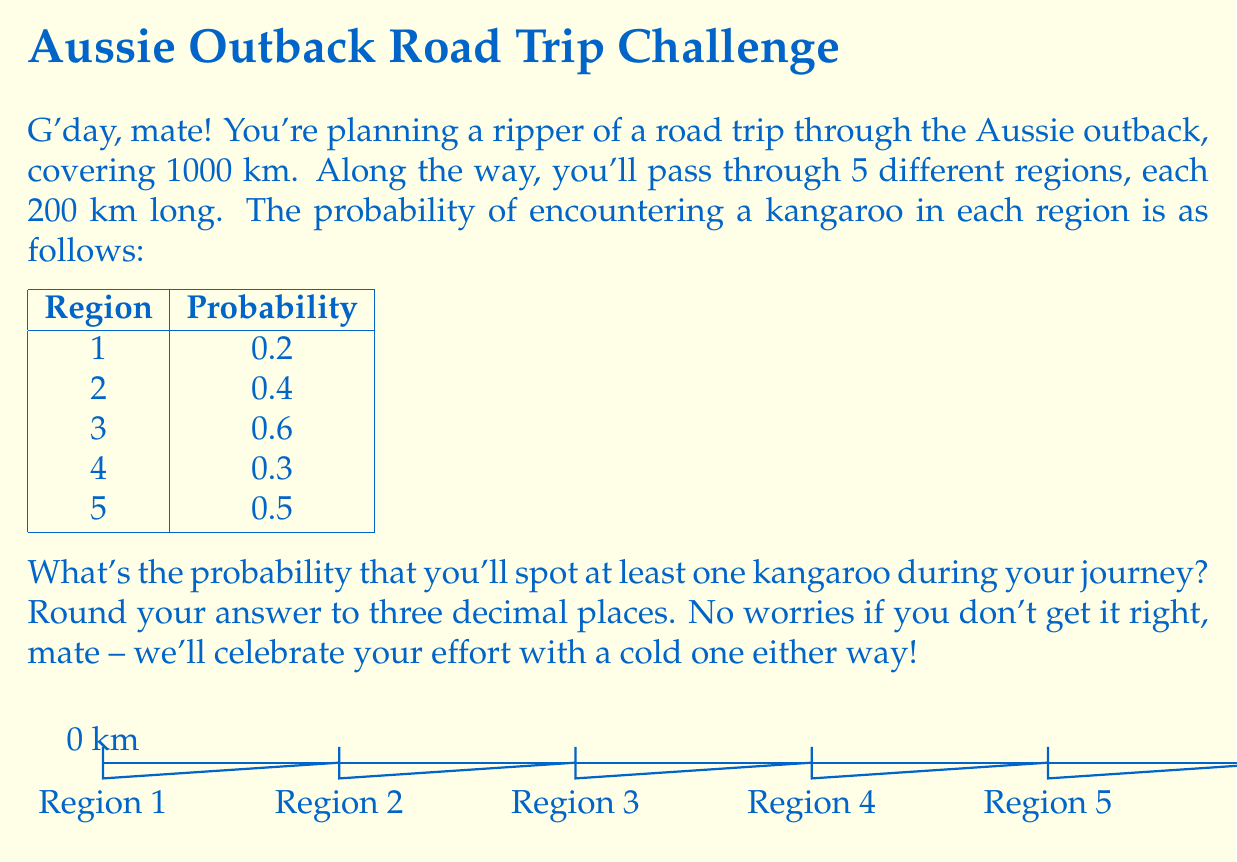Give your solution to this math problem. Let's tackle this problem step by step, mate:

1) First, we need to find the probability of not encountering a kangaroo in each region. This is simply 1 minus the probability of encountering a kangaroo:

   Region 1: $1 - 0.2 = 0.8$
   Region 2: $1 - 0.4 = 0.6$
   Region 3: $1 - 0.6 = 0.4$
   Region 4: $1 - 0.3 = 0.7$
   Region 5: $1 - 0.5 = 0.5$

2) Now, to find the probability of not encountering any kangaroos during the entire trip, we multiply these probabilities together:

   $P(\text{no kangaroos}) = 0.8 \times 0.6 \times 0.4 \times 0.7 \times 0.5$

3) Let's crunch those numbers:

   $P(\text{no kangaroos}) = 0.0672$

4) The probability of encountering at least one kangaroo is the opposite of encountering no kangaroos. So we subtract this probability from 1:

   $P(\text{at least one kangaroo}) = 1 - P(\text{no kangaroos})$
   $= 1 - 0.0672 = 0.9328$

5) Rounding to three decimal places:

   $0.9328 \approx 0.933$

So there you have it! You've got a 93.3% chance of spotting at least one kangaroo on your road trip. Beauty!
Answer: 0.933 